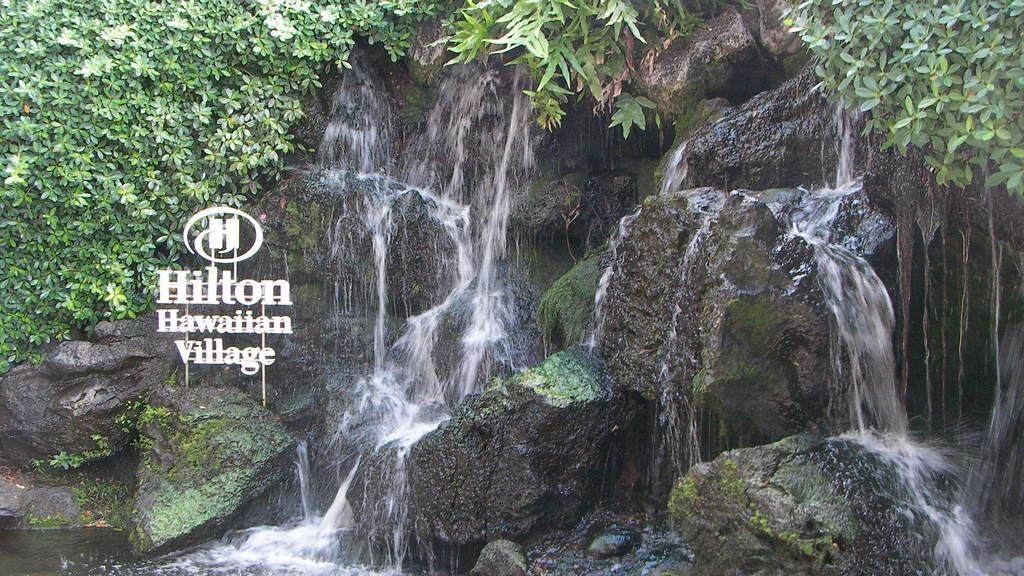Please provide a concise description of this image. In this image we can see there is a waterfall. In the background of the image there are trees. 